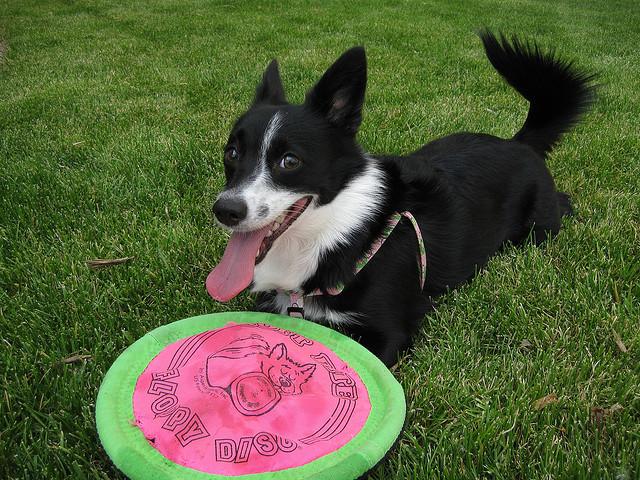Is the dog happy?
Write a very short answer. Yes. Where is the dog?
Keep it brief. Grass. Is that a bowl?
Answer briefly. No. IS the dog drooling?
Concise answer only. No. What toy does the dog have?
Give a very brief answer. Frisbee. Can you see the sky?
Answer briefly. No. What color is the dog?
Quick response, please. Black and white. 